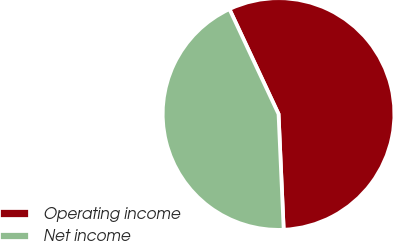Convert chart to OTSL. <chart><loc_0><loc_0><loc_500><loc_500><pie_chart><fcel>Operating income<fcel>Net income<nl><fcel>56.26%<fcel>43.74%<nl></chart> 